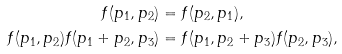Convert formula to latex. <formula><loc_0><loc_0><loc_500><loc_500>f ( p _ { 1 } , p _ { 2 } ) & = f ( p _ { 2 } , p _ { 1 } ) , \\ f ( p _ { 1 } , p _ { 2 } ) f ( p _ { 1 } + p _ { 2 } , p _ { 3 } ) & = f ( p _ { 1 } , p _ { 2 } + p _ { 3 } ) f ( p _ { 2 } , p _ { 3 } ) ,</formula> 